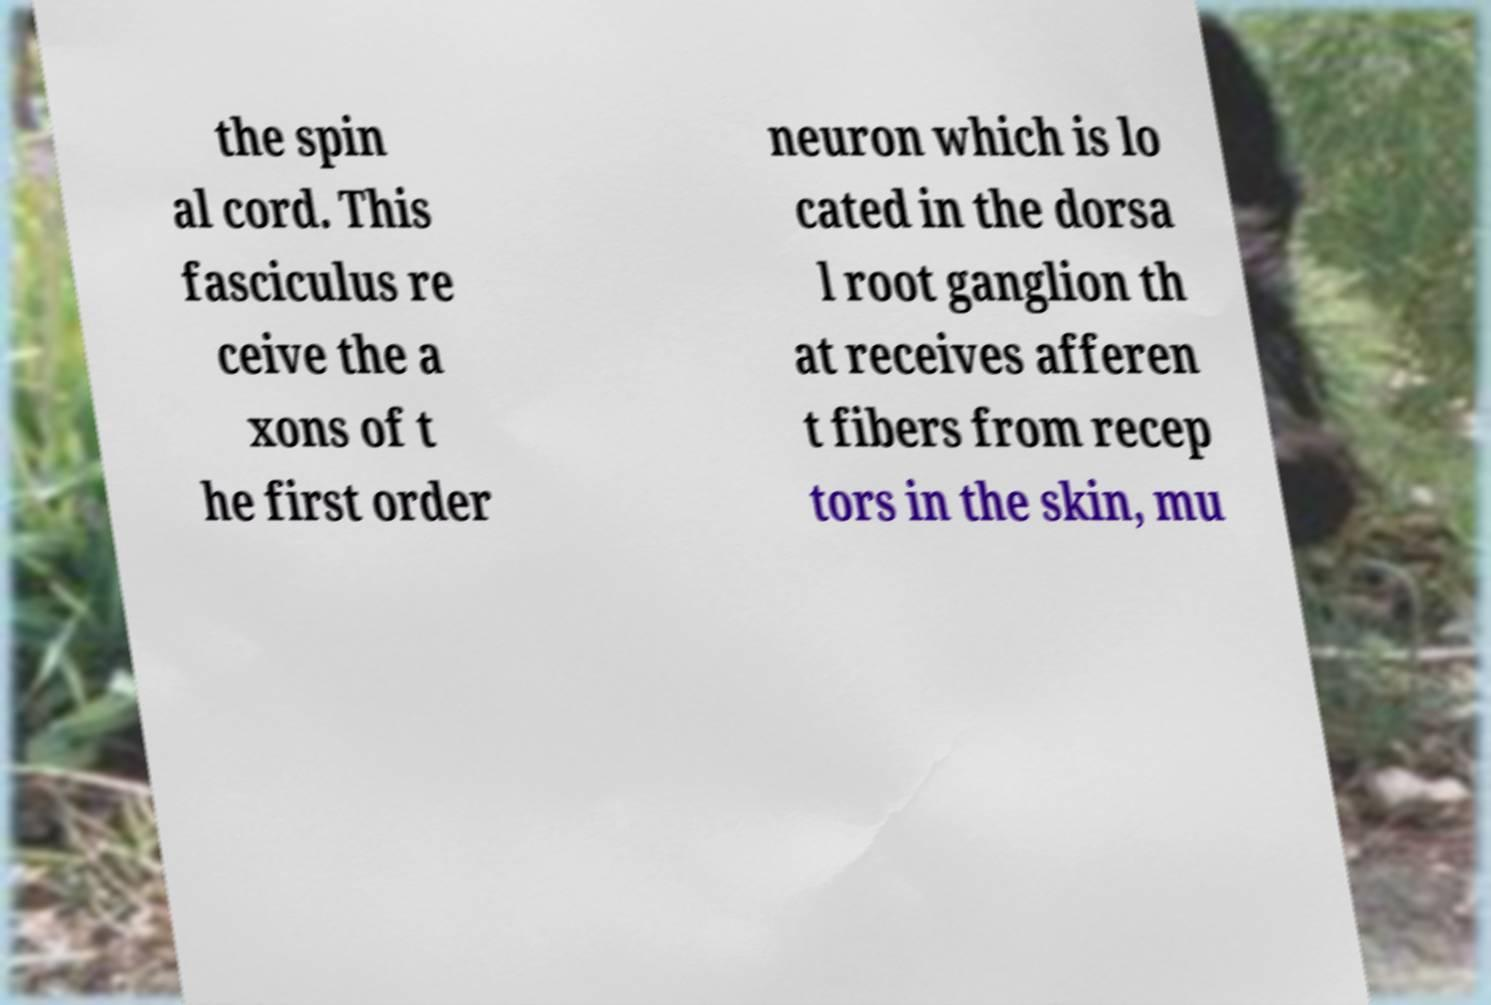Could you extract and type out the text from this image? the spin al cord. This fasciculus re ceive the a xons of t he first order neuron which is lo cated in the dorsa l root ganglion th at receives afferen t fibers from recep tors in the skin, mu 